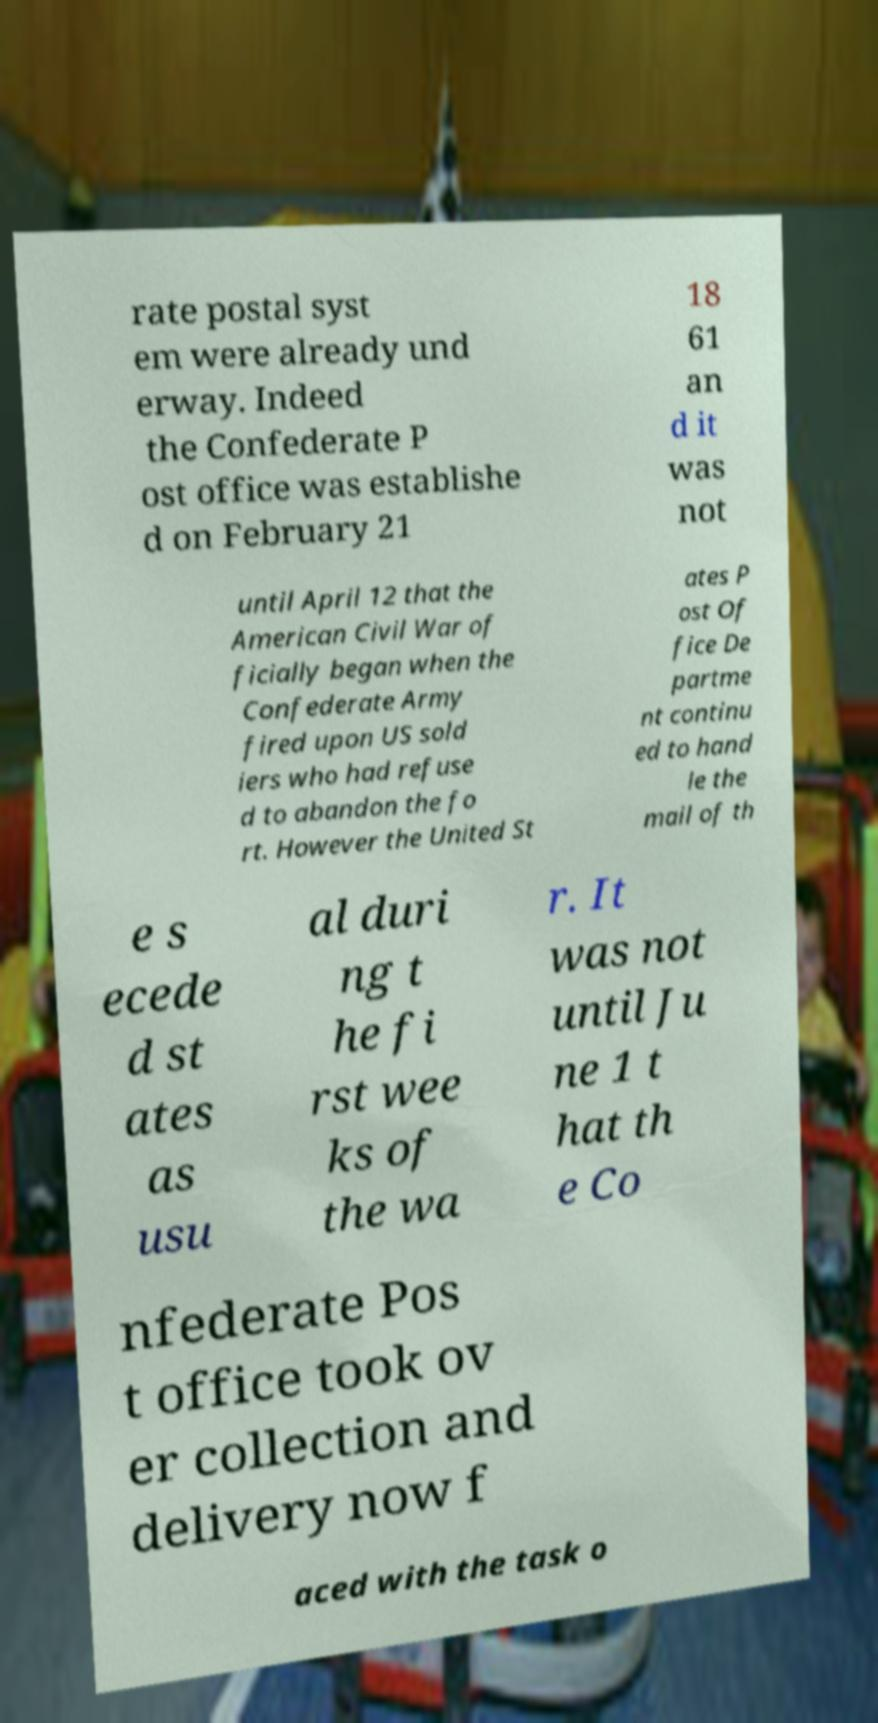What messages or text are displayed in this image? I need them in a readable, typed format. rate postal syst em were already und erway. Indeed the Confederate P ost office was establishe d on February 21 18 61 an d it was not until April 12 that the American Civil War of ficially began when the Confederate Army fired upon US sold iers who had refuse d to abandon the fo rt. However the United St ates P ost Of fice De partme nt continu ed to hand le the mail of th e s ecede d st ates as usu al duri ng t he fi rst wee ks of the wa r. It was not until Ju ne 1 t hat th e Co nfederate Pos t office took ov er collection and delivery now f aced with the task o 